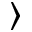<formula> <loc_0><loc_0><loc_500><loc_500>\rangle</formula> 